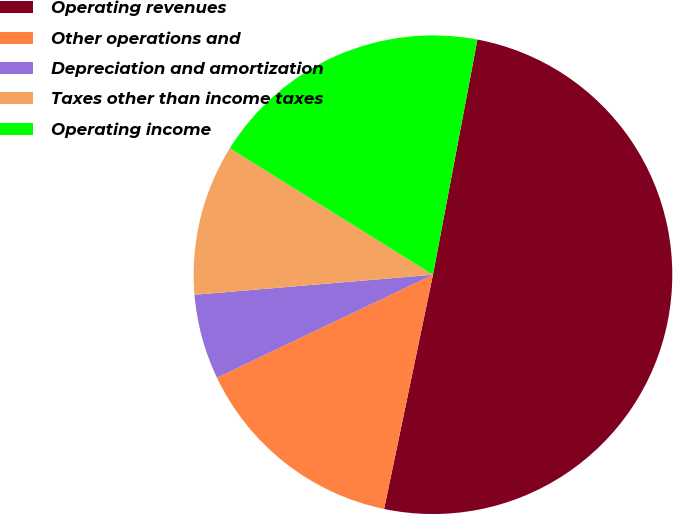<chart> <loc_0><loc_0><loc_500><loc_500><pie_chart><fcel>Operating revenues<fcel>Other operations and<fcel>Depreciation and amortization<fcel>Taxes other than income taxes<fcel>Operating income<nl><fcel>50.3%<fcel>14.65%<fcel>5.74%<fcel>10.2%<fcel>19.11%<nl></chart> 